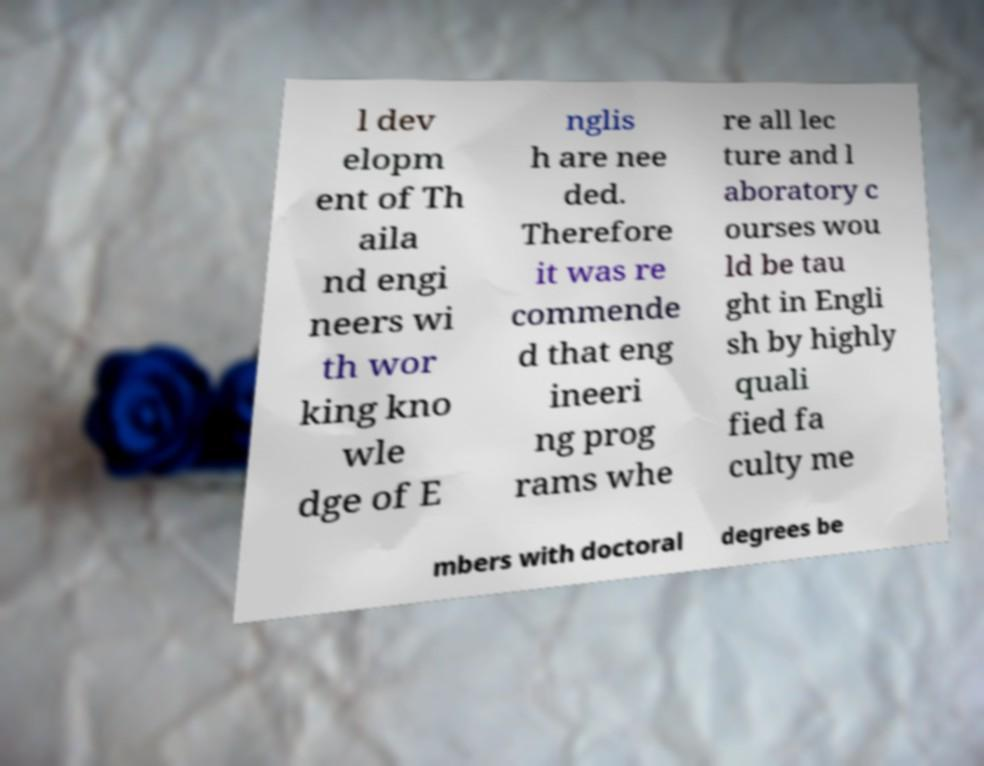Could you assist in decoding the text presented in this image and type it out clearly? l dev elopm ent of Th aila nd engi neers wi th wor king kno wle dge of E nglis h are nee ded. Therefore it was re commende d that eng ineeri ng prog rams whe re all lec ture and l aboratory c ourses wou ld be tau ght in Engli sh by highly quali fied fa culty me mbers with doctoral degrees be 